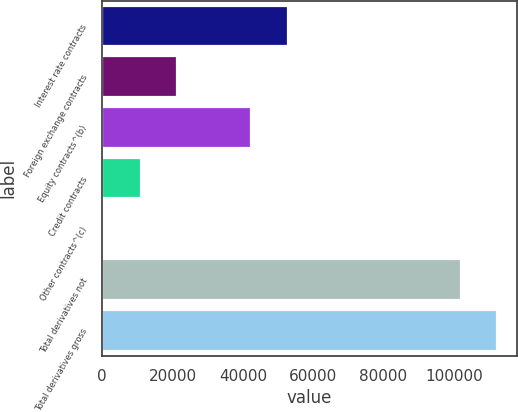Convert chart to OTSL. <chart><loc_0><loc_0><loc_500><loc_500><bar_chart><fcel>Interest rate contracts<fcel>Foreign exchange contracts<fcel>Equity contracts^(b)<fcel>Credit contracts<fcel>Other contracts^(c)<fcel>Total derivatives not<fcel>Total derivatives gross<nl><fcel>52724.6<fcel>21213.2<fcel>42387<fcel>10875.6<fcel>538<fcel>101991<fcel>112329<nl></chart> 